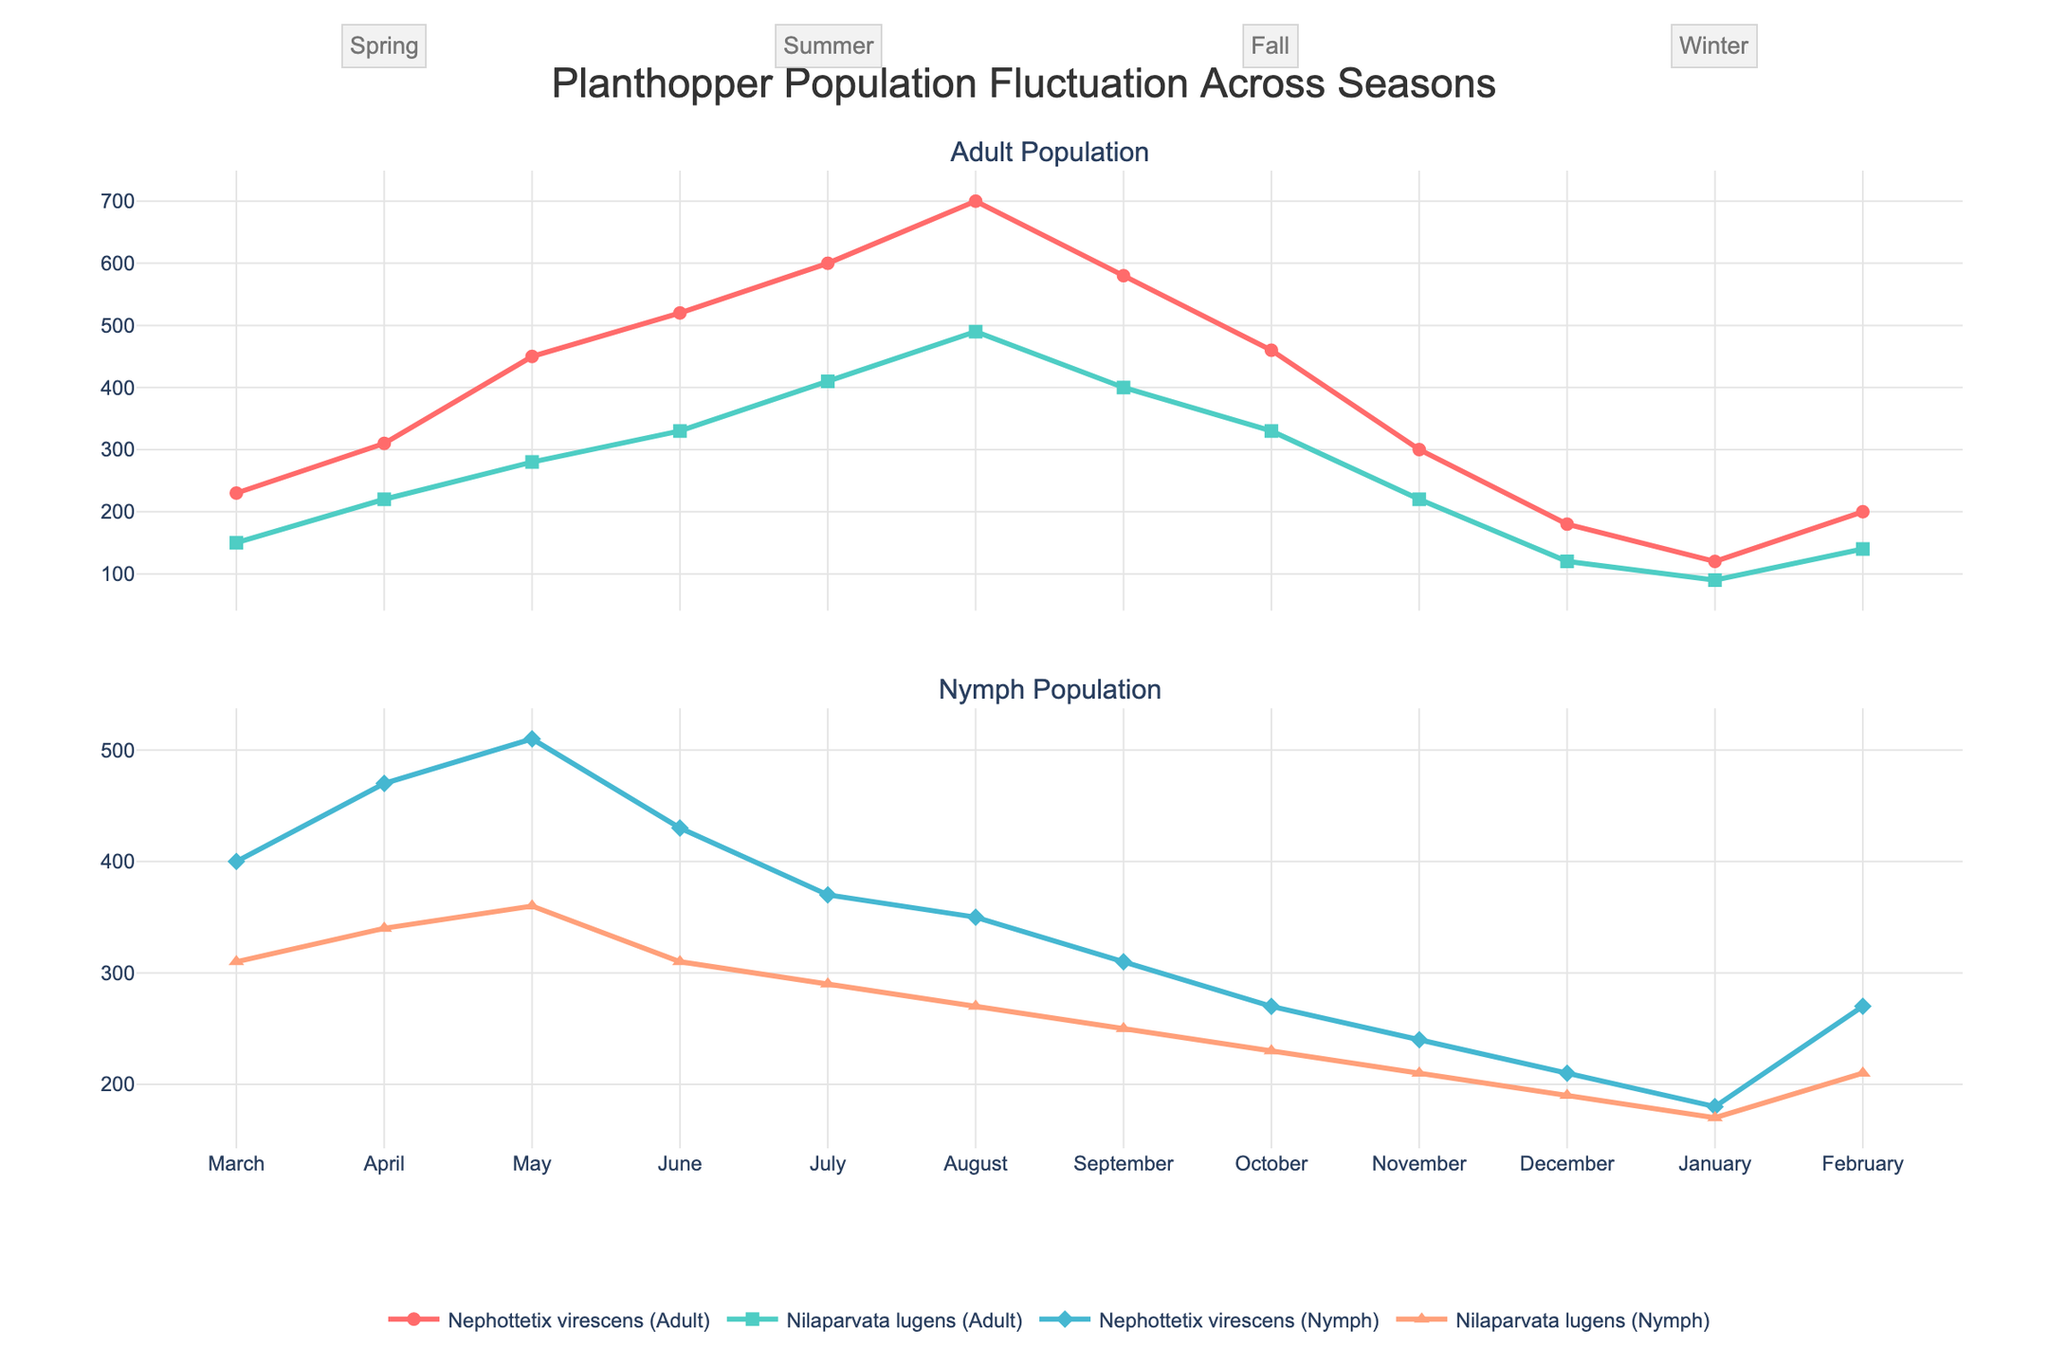What is the title of the plot? The title is usually displayed at the top of the plot. Here, it reads "Planthopper Population Fluctuation Across Seasons."
Answer: Planthopper Population Fluctuation Across Seasons Which season exhibits the highest adult population for Nephottetix virescens? To determine which season exhibits the highest adult population for Nephottetix virescens, look at the peak in the top subplot for "Nephottetix virescens (Adult)." The highest population occurs in August, which is in the Summer.
Answer: Summer How does the nymph population of Nilaparvata lugens change from May to June? First, find the nymph population of Nilaparvata lugens in May and June in the bottom subplot. In May, the population is 360, and in June, it drops to 310. Thus, there's a decrease of 50 in population.
Answer: It decreases by 50 During which month does the adult population of Nilaparvata lugens reach its peak? Locate the peak of the Nilaparvata lugens adult population in the top subplot. The highest point is in August.
Answer: August Compare the nymph population of Nephottetix virescens in Spring with that in Winter. Which is higher? For Spring, sum the nymph populations from March to May (400, 470, 510). The total is 1380. For Winter, sum December to February (210, 180, 270), totaling 660. Spring has a higher population of nymphs.
Answer: Spring What is the main difference observed in the adult populations of the two species during the Winter months? The main noticeable difference is that both species show a substantial drop in adult populations during Winter, but the drop for Nephottetix virescens is more pronounced than for Nilaparvata lugens.
Answer: Nephottetix virescens has a more pronounced drop Calculate the average monthly adult population of Nilaparvata lugens during Fall. Summarize the population for September, October, and November (400, 330, and 220), which gives a total of 950. Divide by 3 months: 950 / 3 = approximately 316.67.
Answer: Approximately 316.67 Do Nephottetix virescens adults or nymphs have a higher population in November? Check the subplot values for Nephottetix virescens in November. Adults are at 300, while nymphs are at 240. The adult population is higher.
Answer: Adults Is there any month where the adult population of Nilaparvata lugens overtakes that of Nephottetix virescens? By examining the top subplot, we see no month where the Nilaparvata lugens adult population exceeds the Nephottetix virescens adult population.
Answer: No How does the adult population trend of Nephottetix virescens differ from Nilaparvata lugens across the four seasons? Observe the overall trends in the top subplot for both species. Nephottetix virescens shows a consistent rise until Summer, then a decline, whereas Nilaparvata lugens has a similar pattern but at a generally lower population level.
Answer: Nephottetix virescens shows generally higher values and larger seasonal changes 